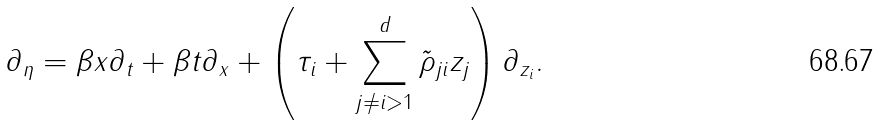Convert formula to latex. <formula><loc_0><loc_0><loc_500><loc_500>\partial _ { \eta } = \beta x \partial _ { t } + \beta t \partial _ { x } + \left ( \tau _ { i } + \sum _ { j \neq i > 1 } ^ { d } \tilde { \rho } _ { j i } { z } _ { j } \right ) \partial _ { z _ { i } } .</formula> 